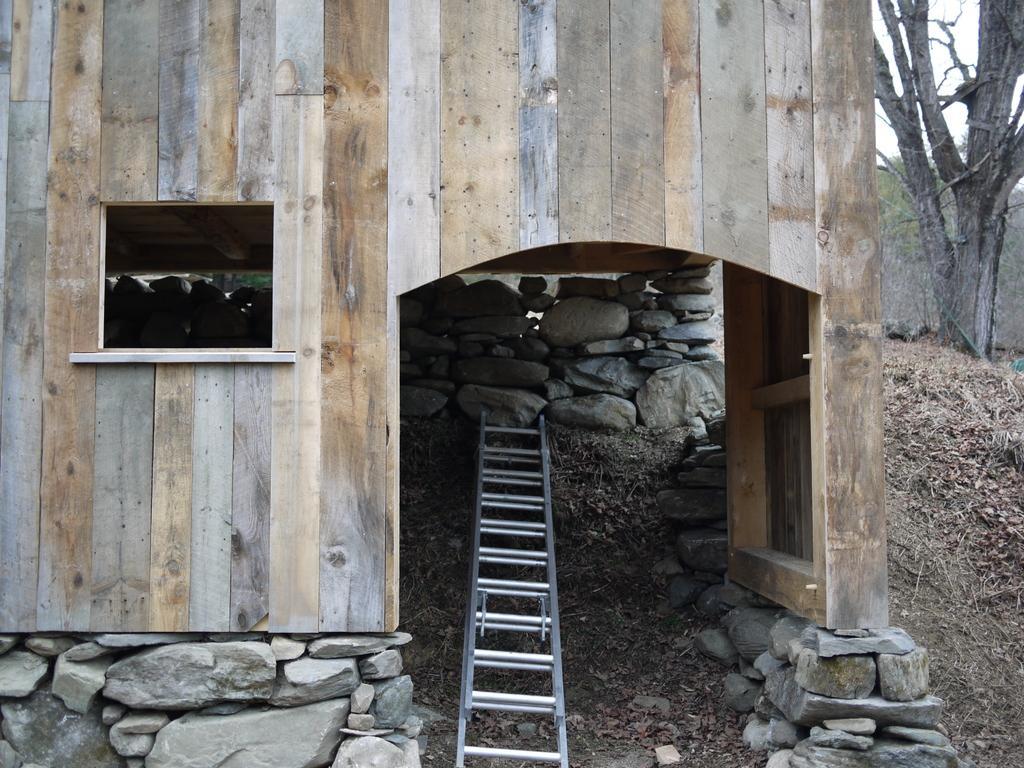Please provide a concise description of this image. In this image it seems like there is a wooden house. Under the wooden house there are stones which are kept one above the other. In the middle there is a metal ladder. There are stones on either side of the ladder. On the right side top there is a tree. At the bottom there is a ground on which there are dry leaves and sand. 